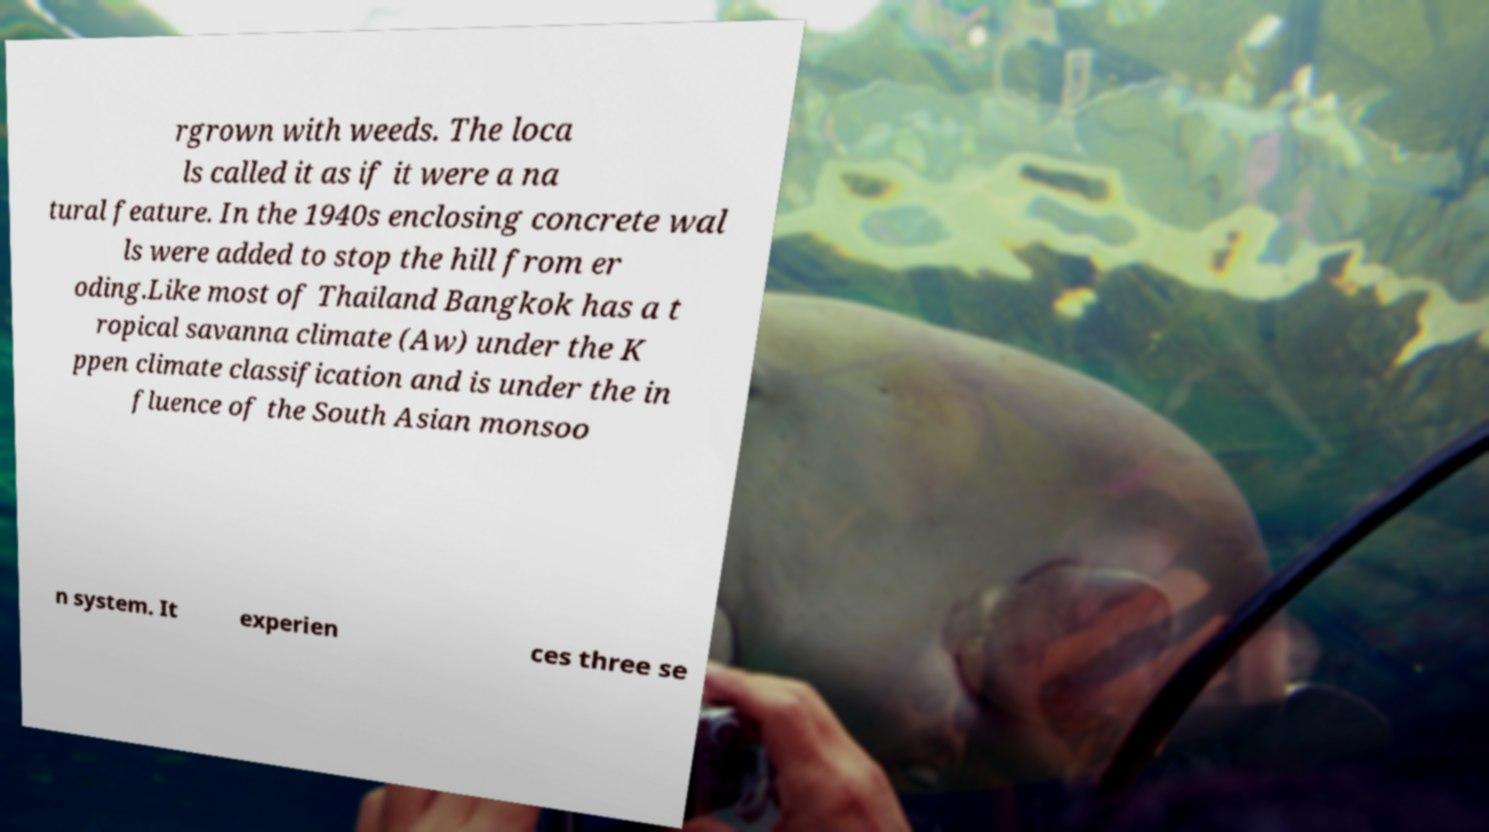Please read and relay the text visible in this image. What does it say? rgrown with weeds. The loca ls called it as if it were a na tural feature. In the 1940s enclosing concrete wal ls were added to stop the hill from er oding.Like most of Thailand Bangkok has a t ropical savanna climate (Aw) under the K ppen climate classification and is under the in fluence of the South Asian monsoo n system. It experien ces three se 